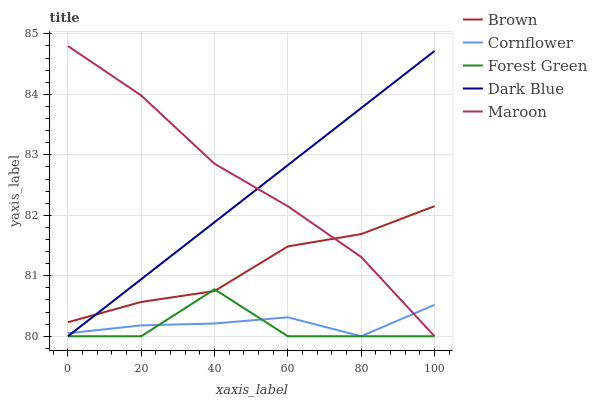Does Forest Green have the minimum area under the curve?
Answer yes or no. Yes. Does Maroon have the maximum area under the curve?
Answer yes or no. Yes. Does Dark Blue have the minimum area under the curve?
Answer yes or no. No. Does Dark Blue have the maximum area under the curve?
Answer yes or no. No. Is Dark Blue the smoothest?
Answer yes or no. Yes. Is Forest Green the roughest?
Answer yes or no. Yes. Is Forest Green the smoothest?
Answer yes or no. No. Is Dark Blue the roughest?
Answer yes or no. No. Does Maroon have the highest value?
Answer yes or no. Yes. Does Forest Green have the highest value?
Answer yes or no. No. Is Cornflower less than Brown?
Answer yes or no. Yes. Is Brown greater than Cornflower?
Answer yes or no. Yes. Does Cornflower intersect Maroon?
Answer yes or no. Yes. Is Cornflower less than Maroon?
Answer yes or no. No. Is Cornflower greater than Maroon?
Answer yes or no. No. Does Cornflower intersect Brown?
Answer yes or no. No. 